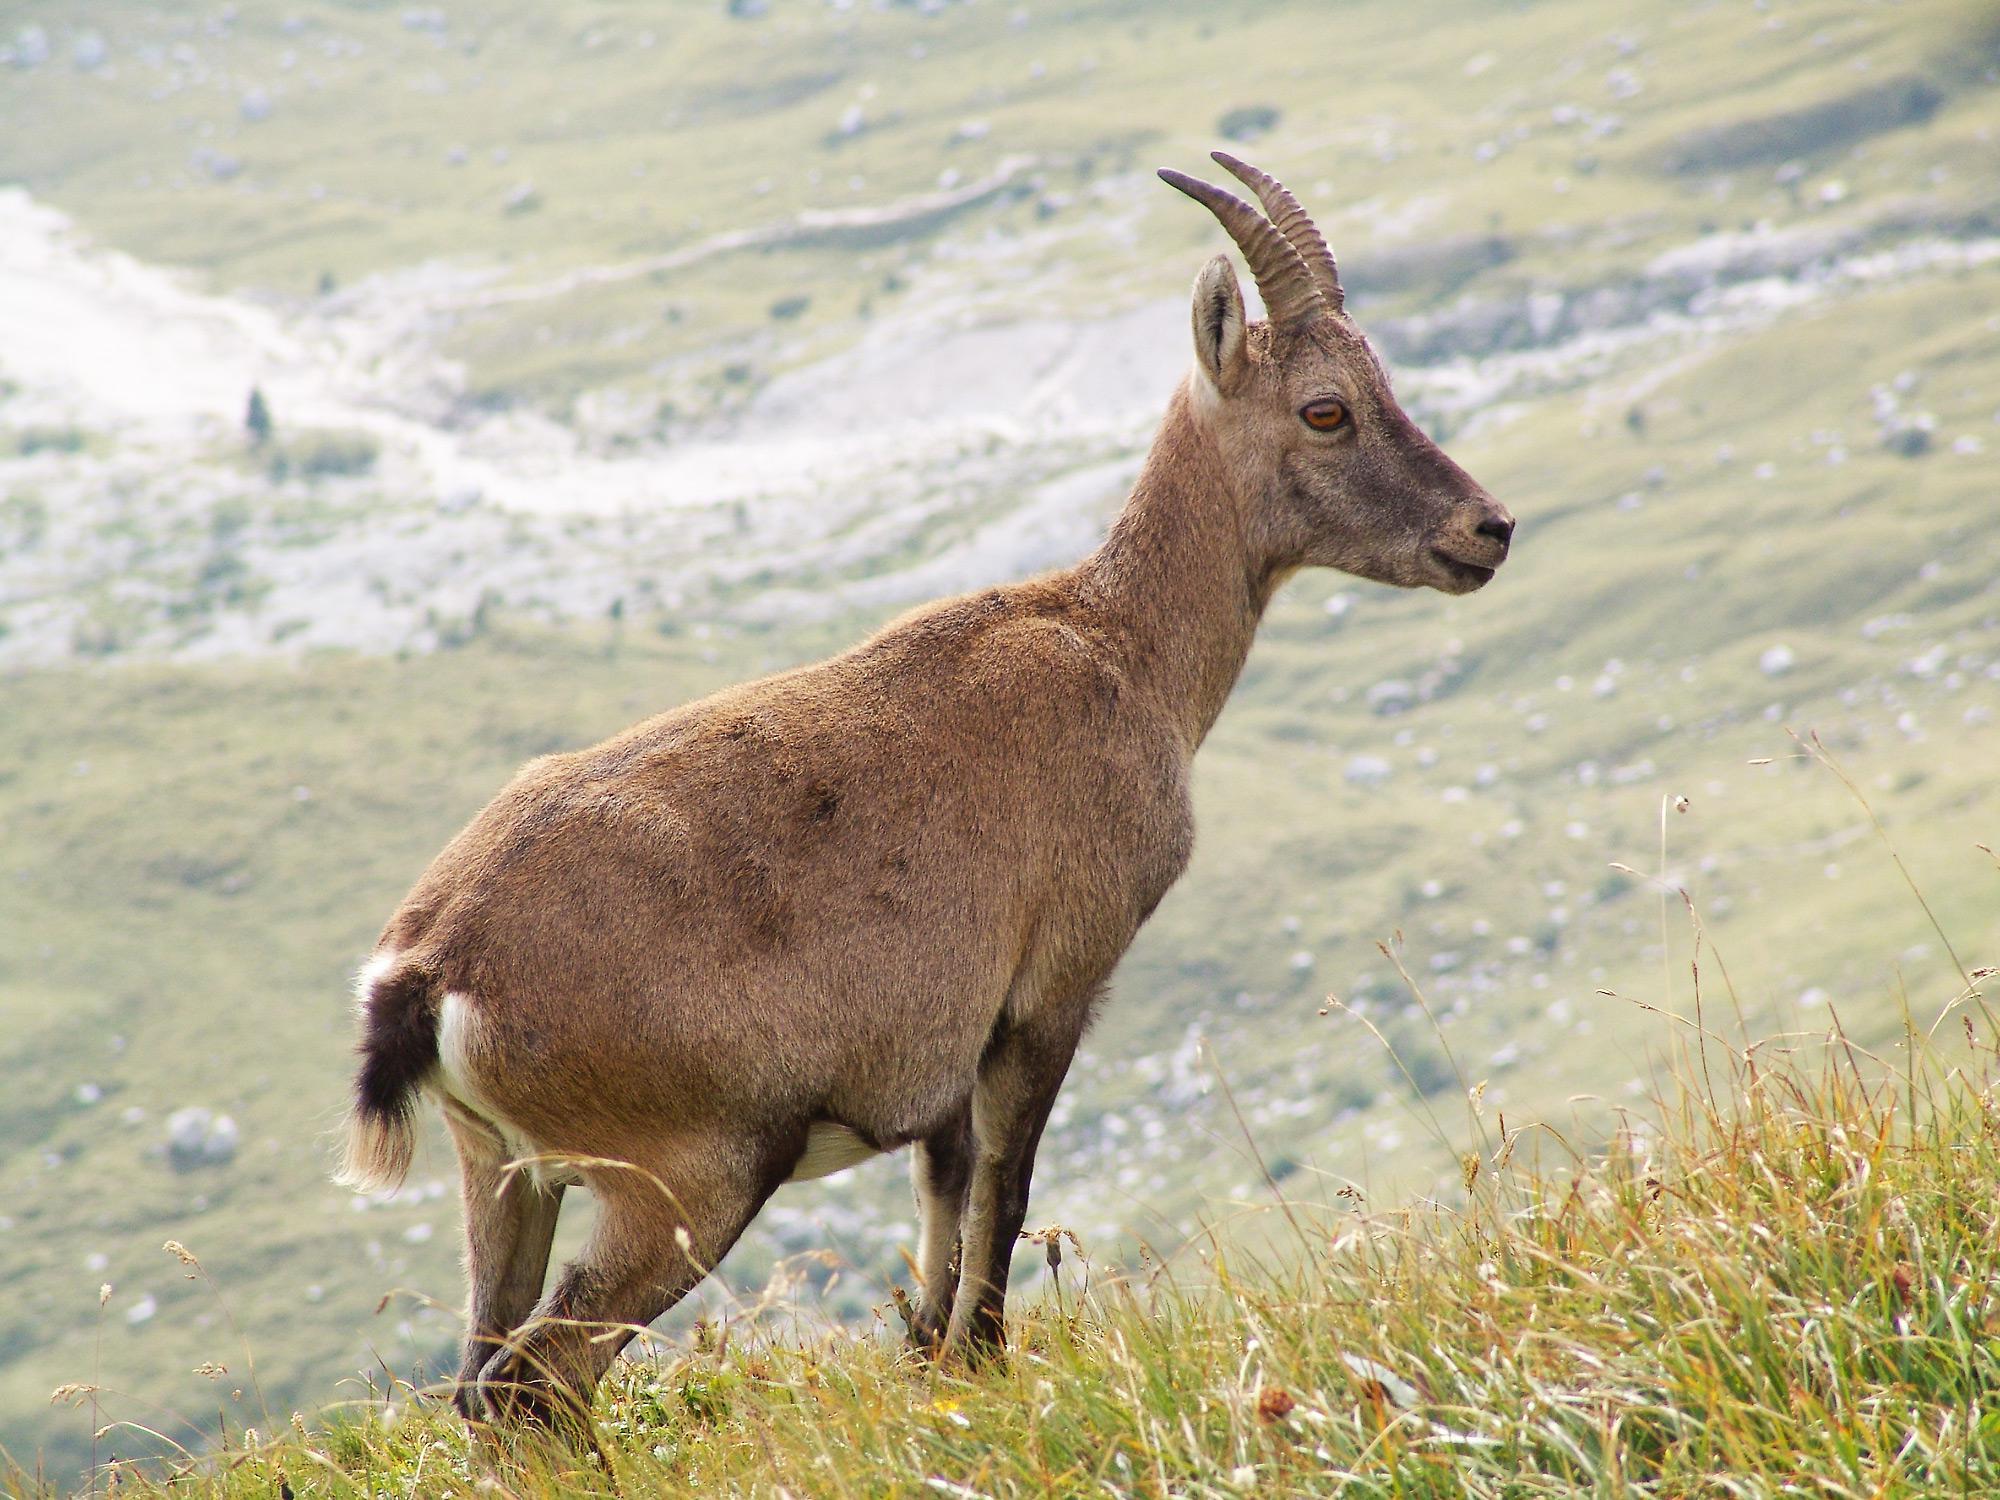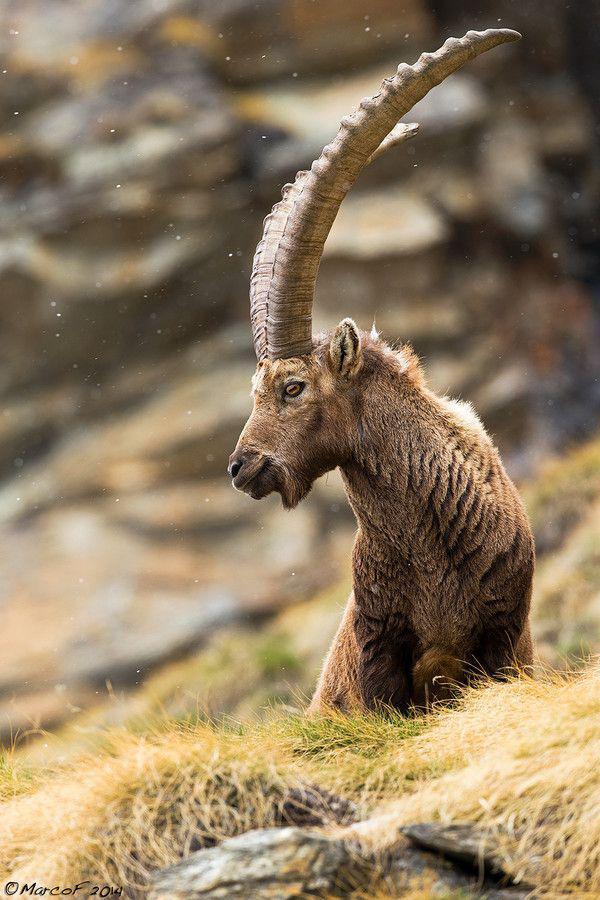The first image is the image on the left, the second image is the image on the right. Given the left and right images, does the statement "The animal in the image on the right is sitting and resting." hold true? Answer yes or no. Yes. The first image is the image on the left, the second image is the image on the right. Examine the images to the left and right. Is the description "A horned animal has both front legs off the ground in one image." accurate? Answer yes or no. No. 